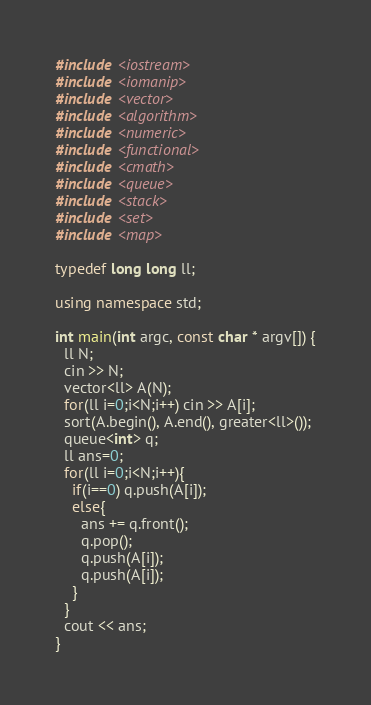<code> <loc_0><loc_0><loc_500><loc_500><_C++_>#include <iostream>
#include <iomanip>
#include <vector>
#include <algorithm>
#include <numeric>
#include <functional>
#include <cmath>
#include <queue>
#include <stack>
#include <set>
#include <map>

typedef long long ll;

using namespace std;

int main(int argc, const char * argv[]) {
  ll N;
  cin >> N;
  vector<ll> A(N);
  for(ll i=0;i<N;i++) cin >> A[i];
  sort(A.begin(), A.end(), greater<ll>());
  queue<int> q;
  ll ans=0;
  for(ll i=0;i<N;i++){
    if(i==0) q.push(A[i]);
    else{
      ans += q.front();
      q.pop();
      q.push(A[i]);
      q.push(A[i]);
    }
  }
  cout << ans;
}

</code> 